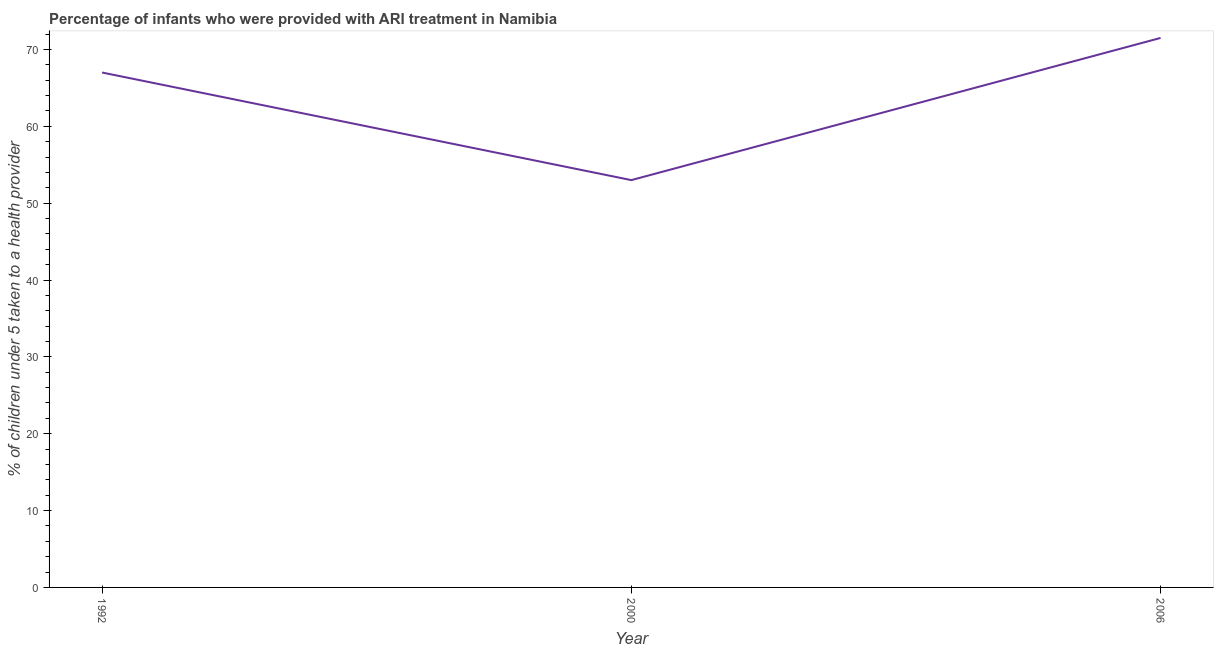What is the percentage of children who were provided with ari treatment in 2006?
Provide a succinct answer. 71.5. Across all years, what is the maximum percentage of children who were provided with ari treatment?
Your response must be concise. 71.5. Across all years, what is the minimum percentage of children who were provided with ari treatment?
Your answer should be very brief. 53. In which year was the percentage of children who were provided with ari treatment minimum?
Provide a succinct answer. 2000. What is the sum of the percentage of children who were provided with ari treatment?
Provide a succinct answer. 191.5. What is the average percentage of children who were provided with ari treatment per year?
Your response must be concise. 63.83. What is the median percentage of children who were provided with ari treatment?
Provide a short and direct response. 67. Do a majority of the years between 2006 and 1992 (inclusive) have percentage of children who were provided with ari treatment greater than 20 %?
Your answer should be compact. No. What is the ratio of the percentage of children who were provided with ari treatment in 1992 to that in 2000?
Offer a terse response. 1.26. Is the percentage of children who were provided with ari treatment in 2000 less than that in 2006?
Provide a short and direct response. Yes. What is the difference between the highest and the second highest percentage of children who were provided with ari treatment?
Make the answer very short. 4.5. Is the sum of the percentage of children who were provided with ari treatment in 2000 and 2006 greater than the maximum percentage of children who were provided with ari treatment across all years?
Ensure brevity in your answer.  Yes. What is the difference between the highest and the lowest percentage of children who were provided with ari treatment?
Ensure brevity in your answer.  18.5. In how many years, is the percentage of children who were provided with ari treatment greater than the average percentage of children who were provided with ari treatment taken over all years?
Offer a terse response. 2. Are the values on the major ticks of Y-axis written in scientific E-notation?
Your answer should be compact. No. Does the graph contain any zero values?
Make the answer very short. No. Does the graph contain grids?
Keep it short and to the point. No. What is the title of the graph?
Offer a very short reply. Percentage of infants who were provided with ARI treatment in Namibia. What is the label or title of the X-axis?
Your answer should be compact. Year. What is the label or title of the Y-axis?
Keep it short and to the point. % of children under 5 taken to a health provider. What is the % of children under 5 taken to a health provider of 1992?
Ensure brevity in your answer.  67. What is the % of children under 5 taken to a health provider of 2000?
Offer a very short reply. 53. What is the % of children under 5 taken to a health provider in 2006?
Your response must be concise. 71.5. What is the difference between the % of children under 5 taken to a health provider in 1992 and 2000?
Provide a short and direct response. 14. What is the difference between the % of children under 5 taken to a health provider in 1992 and 2006?
Keep it short and to the point. -4.5. What is the difference between the % of children under 5 taken to a health provider in 2000 and 2006?
Make the answer very short. -18.5. What is the ratio of the % of children under 5 taken to a health provider in 1992 to that in 2000?
Your response must be concise. 1.26. What is the ratio of the % of children under 5 taken to a health provider in 1992 to that in 2006?
Your response must be concise. 0.94. What is the ratio of the % of children under 5 taken to a health provider in 2000 to that in 2006?
Offer a terse response. 0.74. 